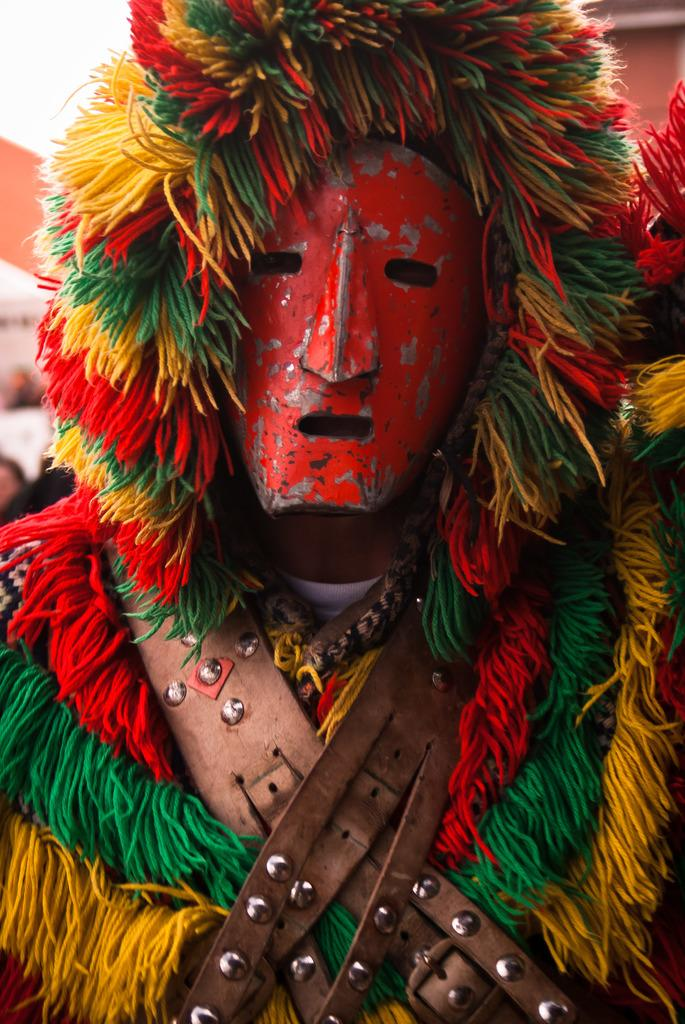What is present in the image? There is a person in the image. How is the person dressed? The person is wearing a different costume. What is covering the person's face? The person's face is covered with a mask. What type of alarm is going off in the image? There is no alarm present in the image. What rule is being enforced by the person in the image? There is no indication of any rule being enforced in the image. 